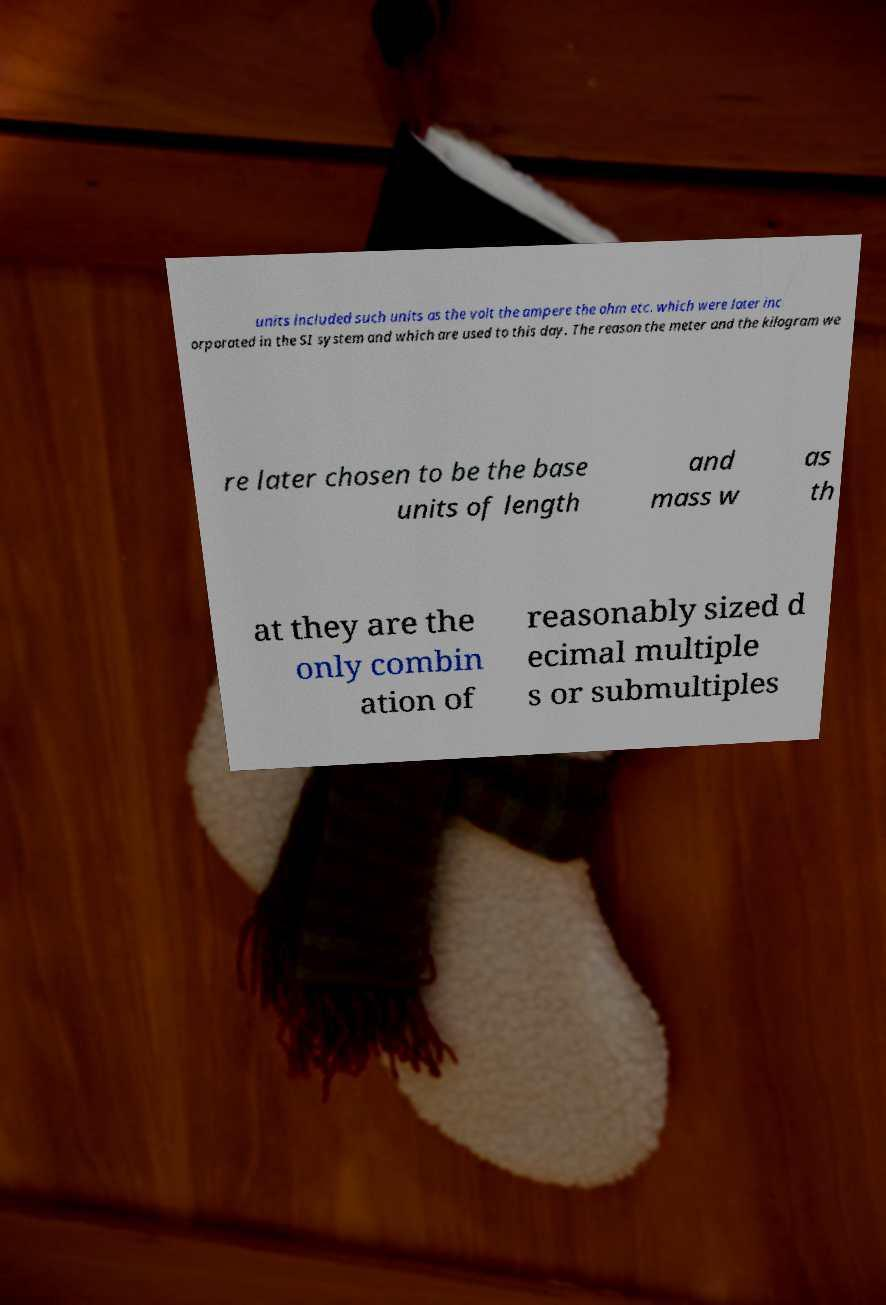What messages or text are displayed in this image? I need them in a readable, typed format. units included such units as the volt the ampere the ohm etc. which were later inc orporated in the SI system and which are used to this day. The reason the meter and the kilogram we re later chosen to be the base units of length and mass w as th at they are the only combin ation of reasonably sized d ecimal multiple s or submultiples 